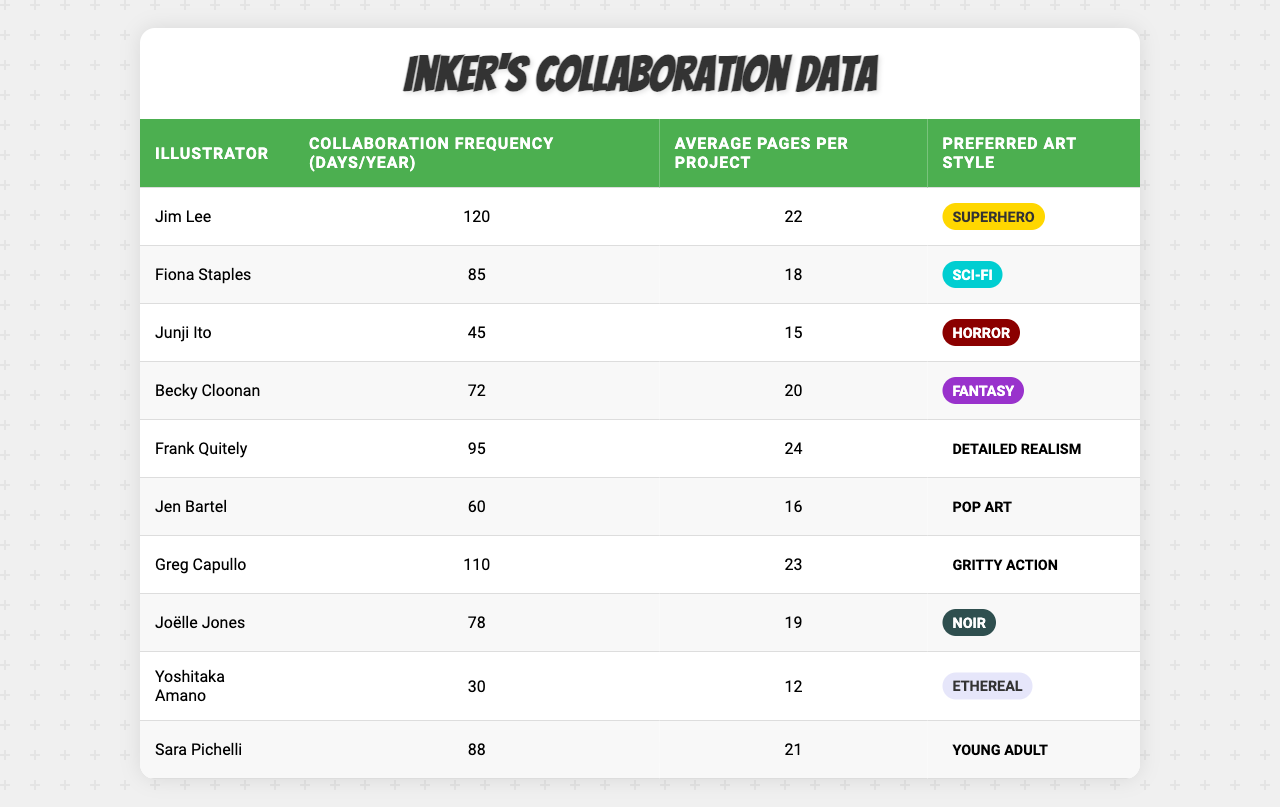What is the collaboration frequency with Jim Lee? The table lists Jim Lee's collaboration frequency as 120 days per year.
Answer: 120 Who has the highest average pages per project? By comparing the average pages per project for each illustrator, Frank Quitely has the highest with 24 pages.
Answer: Frank Quitely Is the preferred art style of Junji Ito horror? The table categorizes Junji Ito's preferred art style as horror, which confirms the statement.
Answer: Yes How many illustrators collaborate more than 100 days per year? Analyzing the table, 4 illustrators (Jim Lee, Greg Capullo, Frank Quitely, and Yoshitaka Amano) have collaboration frequencies over 100 days.
Answer: 3 What is the average collaboration frequency of all illustrators? Adding all frequencies: (120 + 85 + 45 + 72 + 95 + 60 + 110 + 78 + 30 + 88) = 900; then dividing by the number of illustrators (10) gives 900/10 = 90.
Answer: 90 Who collaborates the least frequently and what is their style? The least collaboration frequency is from Yoshitaka Amano at 30 days, and his preferred art style is Ethereal.
Answer: Yoshitaka Amano, Ethereal Which illustrator has the lowest average pages per project? The average pages per project for Yoshitaka Amano is 12, making him the illustrator with the lowest average.
Answer: Yoshitaka Amano Are there more illustrators with the sci-fi style or fantasy style? The table shows Fiona Staples with sci-fi and Becky Cloonan with fantasy, indicating there is a tie with one of each.
Answer: Tie What is the total collaboration frequency of illustrators with a preferred art style of "Noir"? Joëlle Jones has a collaboration frequency of 78 days with the Noir style, thus the total is 78.
Answer: 78 Does Greg Capullo's average pages per project exceed 20? Greg Capullo has an average pages per project of 23, which is greater than 20.
Answer: Yes 